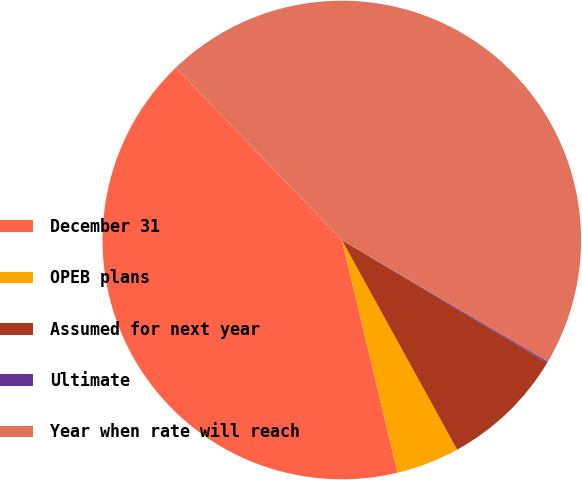<chart> <loc_0><loc_0><loc_500><loc_500><pie_chart><fcel>December 31<fcel>OPEB plans<fcel>Assumed for next year<fcel>Ultimate<fcel>Year when rate will reach<nl><fcel>41.53%<fcel>4.26%<fcel>8.41%<fcel>0.1%<fcel>45.69%<nl></chart> 